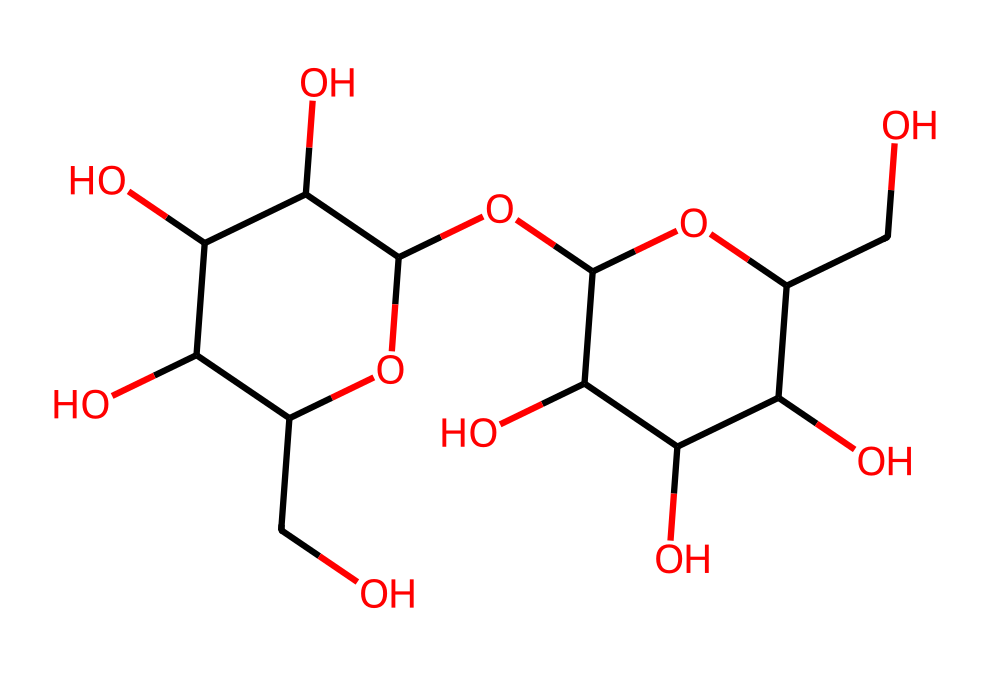What is the main component of this molecule? The structure represented is a polysaccharide, specifically starch, which is a carbohydrate made of multiple glucose units.
Answer: starch How many rings are present in the structure? The structure contains two six-membered rings, which are part of the glucose units that make up starch.
Answer: two What is the total number of oxygen atoms in this molecule? By counting the oxygen atoms present in both glucose units, the total comes to six oxygen atoms within the entire structure of starch.
Answer: six What type of glycosidic bond is found in this molecule? The connections between the glucose units indicate that alpha-1,4-glycosidic bonds are present, typical for starch molecules.
Answer: alpha-1,4-glycosidic What role does this carbohydrate play in traditional bread? Starch serves primarily as an energy storage form within plants and is a major source of carbohydrates in bread, providing energy upon digestion.
Answer: energy source How many carbon atoms does this molecule contain? This molecule features a total of twelve carbon atoms that are part of the glucose monomers linked together in the starch structure.
Answer: twelve What is the primary dietary benefit of consuming starch in bread? Starch is known to provide essential carbohydrates that supply energy for bodily functions and activities, making it vital in diets.
Answer: energy supply 